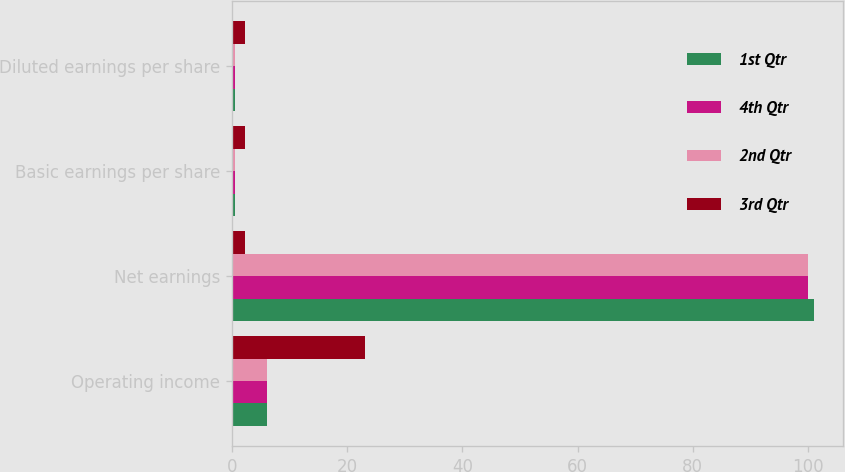<chart> <loc_0><loc_0><loc_500><loc_500><stacked_bar_chart><ecel><fcel>Operating income<fcel>Net earnings<fcel>Basic earnings per share<fcel>Diluted earnings per share<nl><fcel>1st Qtr<fcel>6<fcel>101<fcel>0.58<fcel>0.58<nl><fcel>4th Qtr<fcel>6<fcel>100<fcel>0.57<fcel>0.57<nl><fcel>2nd Qtr<fcel>6<fcel>100<fcel>0.58<fcel>0.57<nl><fcel>3rd Qtr<fcel>23<fcel>2.29<fcel>2.29<fcel>2.28<nl></chart> 